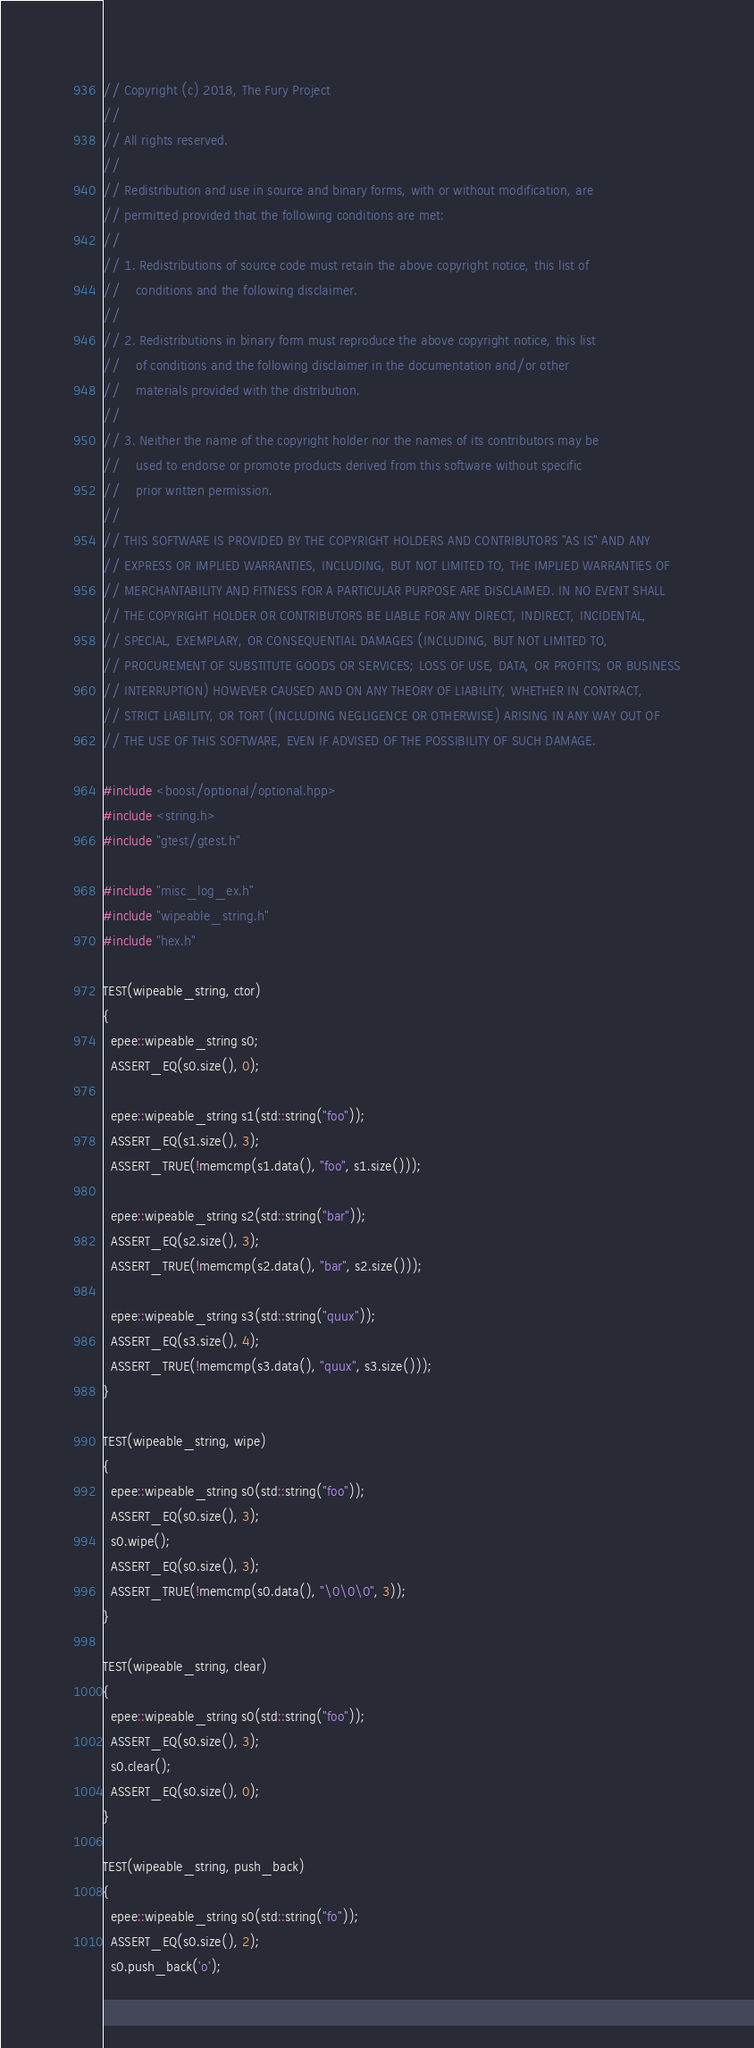Convert code to text. <code><loc_0><loc_0><loc_500><loc_500><_C++_>// Copyright (c) 2018, The Fury Project
// 
// All rights reserved.
// 
// Redistribution and use in source and binary forms, with or without modification, are
// permitted provided that the following conditions are met:
// 
// 1. Redistributions of source code must retain the above copyright notice, this list of
//    conditions and the following disclaimer.
// 
// 2. Redistributions in binary form must reproduce the above copyright notice, this list
//    of conditions and the following disclaimer in the documentation and/or other
//    materials provided with the distribution.
// 
// 3. Neither the name of the copyright holder nor the names of its contributors may be
//    used to endorse or promote products derived from this software without specific
//    prior written permission.
// 
// THIS SOFTWARE IS PROVIDED BY THE COPYRIGHT HOLDERS AND CONTRIBUTORS "AS IS" AND ANY
// EXPRESS OR IMPLIED WARRANTIES, INCLUDING, BUT NOT LIMITED TO, THE IMPLIED WARRANTIES OF
// MERCHANTABILITY AND FITNESS FOR A PARTICULAR PURPOSE ARE DISCLAIMED. IN NO EVENT SHALL
// THE COPYRIGHT HOLDER OR CONTRIBUTORS BE LIABLE FOR ANY DIRECT, INDIRECT, INCIDENTAL,
// SPECIAL, EXEMPLARY, OR CONSEQUENTIAL DAMAGES (INCLUDING, BUT NOT LIMITED TO,
// PROCUREMENT OF SUBSTITUTE GOODS OR SERVICES; LOSS OF USE, DATA, OR PROFITS; OR BUSINESS
// INTERRUPTION) HOWEVER CAUSED AND ON ANY THEORY OF LIABILITY, WHETHER IN CONTRACT,
// STRICT LIABILITY, OR TORT (INCLUDING NEGLIGENCE OR OTHERWISE) ARISING IN ANY WAY OUT OF
// THE USE OF THIS SOFTWARE, EVEN IF ADVISED OF THE POSSIBILITY OF SUCH DAMAGE.

#include <boost/optional/optional.hpp>
#include <string.h>
#include "gtest/gtest.h"

#include "misc_log_ex.h"
#include "wipeable_string.h"
#include "hex.h"

TEST(wipeable_string, ctor)
{
  epee::wipeable_string s0;
  ASSERT_EQ(s0.size(), 0);

  epee::wipeable_string s1(std::string("foo"));
  ASSERT_EQ(s1.size(), 3);
  ASSERT_TRUE(!memcmp(s1.data(), "foo", s1.size()));

  epee::wipeable_string s2(std::string("bar"));
  ASSERT_EQ(s2.size(), 3);
  ASSERT_TRUE(!memcmp(s2.data(), "bar", s2.size()));

  epee::wipeable_string s3(std::string("quux"));
  ASSERT_EQ(s3.size(), 4);
  ASSERT_TRUE(!memcmp(s3.data(), "quux", s3.size()));
}

TEST(wipeable_string, wipe)
{
  epee::wipeable_string s0(std::string("foo"));
  ASSERT_EQ(s0.size(), 3);
  s0.wipe();
  ASSERT_EQ(s0.size(), 3);
  ASSERT_TRUE(!memcmp(s0.data(), "\0\0\0", 3));
}

TEST(wipeable_string, clear)
{
  epee::wipeable_string s0(std::string("foo"));
  ASSERT_EQ(s0.size(), 3);
  s0.clear();
  ASSERT_EQ(s0.size(), 0);
}

TEST(wipeable_string, push_back)
{
  epee::wipeable_string s0(std::string("fo"));
  ASSERT_EQ(s0.size(), 2);
  s0.push_back('o');</code> 